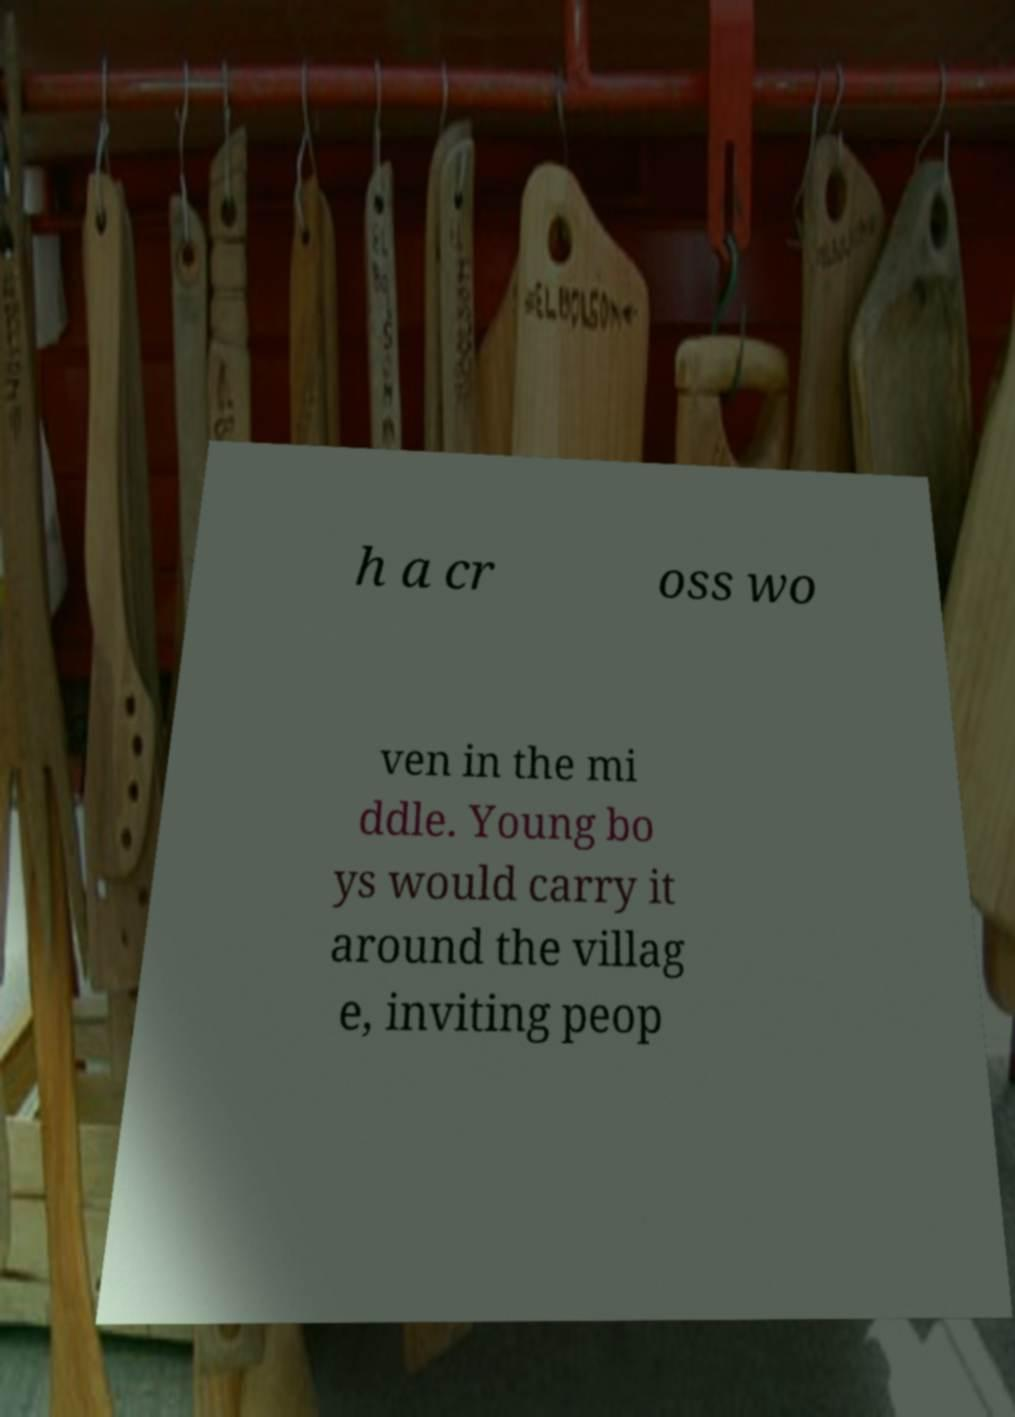I need the written content from this picture converted into text. Can you do that? h a cr oss wo ven in the mi ddle. Young bo ys would carry it around the villag e, inviting peop 